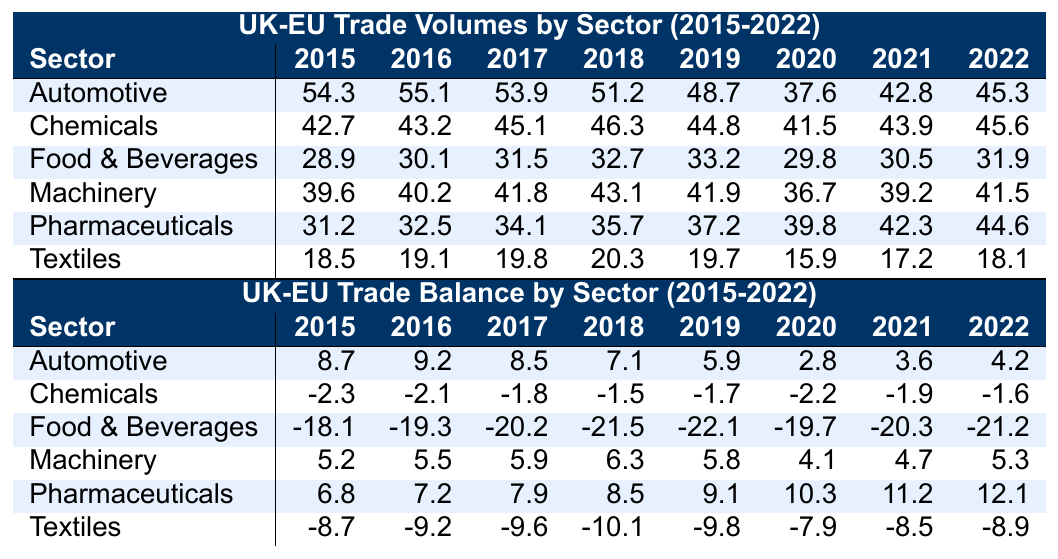What was the trade volume for Pharmaceuticals in 2020? Looking at the Pharmaceuticals row for the year 2020, the trade volume is listed as 39.8.
Answer: 39.8 Which sector had the highest trade volume in 2016? Reviewing the trade volumes for each sector in 2016, Automotive has the highest volume of 55.1.
Answer: Automotive What is the trade balance for Food & Beverages in 2019? Checking the Food & Beverages row for 2019, the trade balance is -22.1.
Answer: -22.1 Which sector experienced the largest decrease in trade volume from 2019 to 2020? Calculating the difference for each sector: Automotive (48.7 - 37.6 = 11.1), Chemicals (44.8 - 41.5 = 3.3), Food & Beverages (33.2 - 29.8 = 3.4), Machinery (41.9 - 36.7 = 5.2), Pharmaceuticals (37.2 - 39.8 = -2.6), Textiles (19.7 - 15.9 = 3.8). The largest decrease is 11.1 in Automotive.
Answer: Automotive What was the average trade volume for Automotive over the years 2015 to 2022? The trade volumes for Automotive during these years are 54.3, 55.1, 53.9, 51.2, 48.7, 37.6, 42.8, 45.3. Adding these gives 388.9 and dividing by 8 results in an average of 48.61.
Answer: 48.61 Did the trade balance for Chemicals improve from 2020 to 2022? Comparing the trade balances for Chemicals in 2020 (-2.2) and 2022 (-1.6), -1.6 is greater than -2.2, meaning it improved.
Answer: Yes In which year did the Pharmaceuticals sector have the highest trade balance? Looking down the Pharmaceuticals trade balance column, the highest value occurs in 2022, with a balance of 12.1.
Answer: 2022 What is the total trade volume across all sectors in 2021? Summing the trade volumes for all sectors in 2021 gives: 42.8 (Automotive) + 43.9 (Chemicals) + 30.5 (Food & Beverages) + 39.2 (Machinery) + 42.3 (Pharmaceuticals) + 17.2 (Textiles) = 215.9.
Answer: 215.9 Which sector showed consistent negative trade balance throughout the years? Checking the trade balance for each sector reveals that Food & Beverages had negative values every year from 2015 to 2022.
Answer: Food & Beverages What was the percentage change in trade volume for Textiles from 2015 to 2022? The trade volume for Textiles in 2015 was 18.5 and in 2022 was 18.1. The change is (18.1 - 18.5)/18.5 = -0.0216. To find the percentage, multiply by 100: -0.0216 * 100 = -2.16%.
Answer: -2.16% Which sector had the highest increase in trade volume from 2020 to 2021? By calculating the differences from 2020 to 2021: Automotive (42.8 - 37.6 = 5.2), Chemicals (43.9 - 41.5 = 2.4), Food & Beverages (30.5 - 29.8 = 0.7), Machinery (39.2 - 36.7 = 2.5), Pharmaceuticals (42.3 - 39.8 = 2.5), Textiles (17.2 - 15.9 = 1.3). The largest increase is in Automotive at 5.2.
Answer: Automotive 